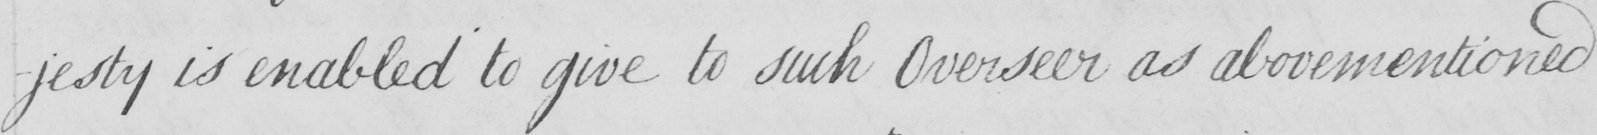Can you tell me what this handwritten text says? -jesty is enabled to give to such Overseer as abovementioned 